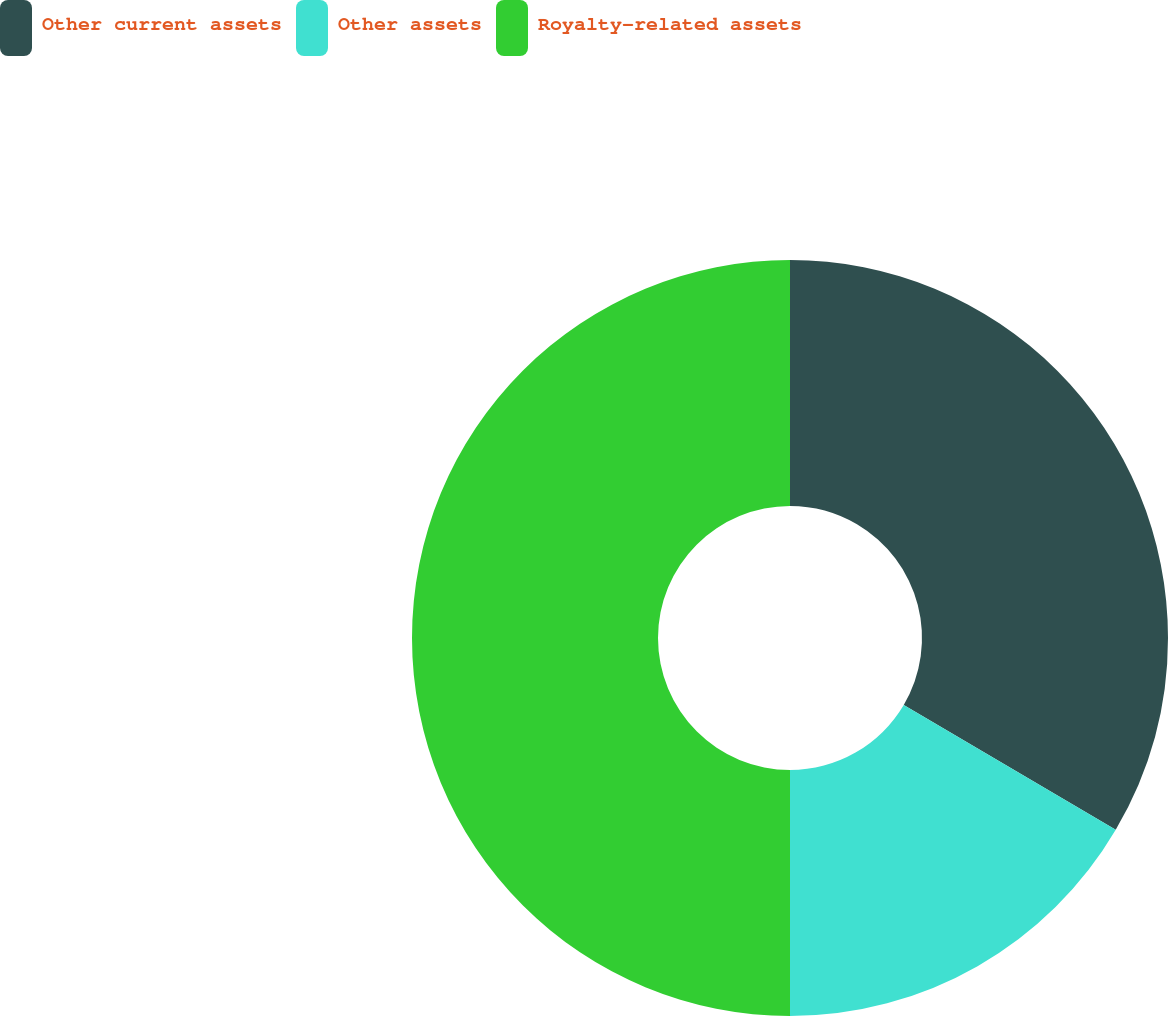Convert chart. <chart><loc_0><loc_0><loc_500><loc_500><pie_chart><fcel>Other current assets<fcel>Other assets<fcel>Royalty-related assets<nl><fcel>33.47%<fcel>16.53%<fcel>50.0%<nl></chart> 